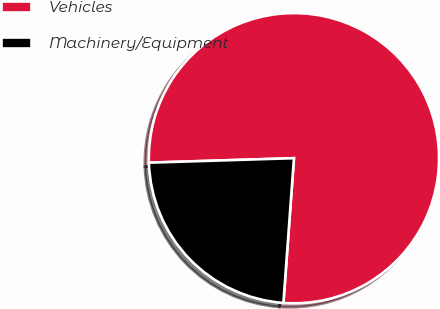<chart> <loc_0><loc_0><loc_500><loc_500><pie_chart><fcel>Vehicles<fcel>Machinery/Equipment<nl><fcel>76.65%<fcel>23.35%<nl></chart> 